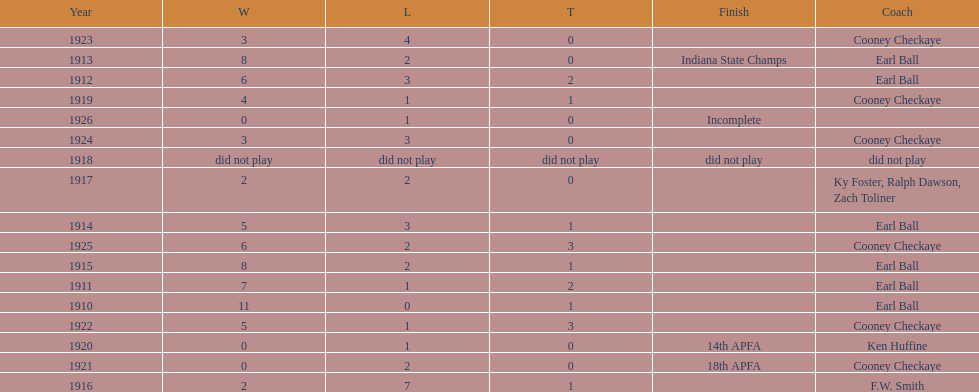In what year did the muncie flyers have an undefeated record? 1910. 